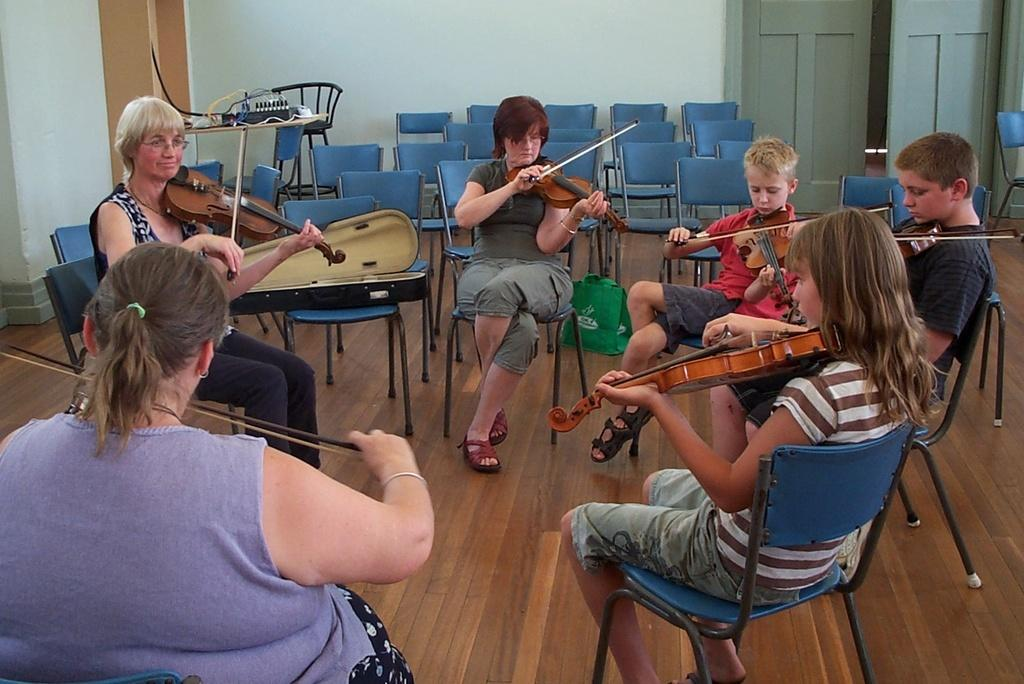What are the students in the image doing? The students in the image are playing the violin. Who is leading the students in the image? There is a teacher in front of the students. What can be seen in the background of the image? There are chairs and a wall in the background of the image. What type of game are the students playing in the image? There is no game being played in the image; the students are playing the violin. 